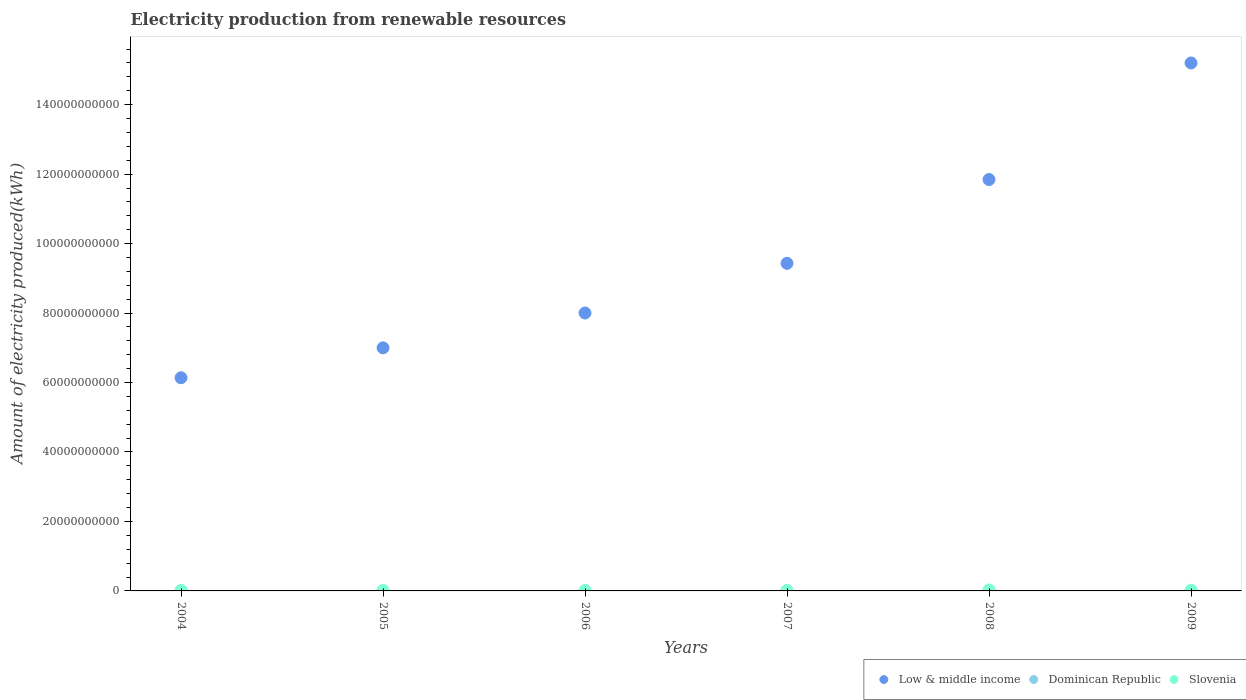How many different coloured dotlines are there?
Give a very brief answer. 3. What is the amount of electricity produced in Low & middle income in 2004?
Provide a short and direct response. 6.14e+1. Across all years, what is the maximum amount of electricity produced in Low & middle income?
Keep it short and to the point. 1.52e+11. Across all years, what is the minimum amount of electricity produced in Low & middle income?
Provide a short and direct response. 6.14e+1. In which year was the amount of electricity produced in Dominican Republic maximum?
Give a very brief answer. 2004. What is the total amount of electricity produced in Low & middle income in the graph?
Give a very brief answer. 5.76e+11. What is the difference between the amount of electricity produced in Low & middle income in 2007 and that in 2008?
Offer a very short reply. -2.41e+1. What is the difference between the amount of electricity produced in Low & middle income in 2006 and the amount of electricity produced in Slovenia in 2005?
Provide a succinct answer. 7.99e+1. What is the average amount of electricity produced in Dominican Republic per year?
Provide a succinct answer. 3.68e+07. In the year 2009, what is the difference between the amount of electricity produced in Low & middle income and amount of electricity produced in Dominican Republic?
Give a very brief answer. 1.52e+11. In how many years, is the amount of electricity produced in Slovenia greater than 128000000000 kWh?
Your answer should be very brief. 0. What is the ratio of the amount of electricity produced in Low & middle income in 2004 to that in 2006?
Give a very brief answer. 0.77. Is the amount of electricity produced in Slovenia in 2006 less than that in 2007?
Offer a very short reply. Yes. Is the difference between the amount of electricity produced in Low & middle income in 2005 and 2007 greater than the difference between the amount of electricity produced in Dominican Republic in 2005 and 2007?
Offer a terse response. No. What is the difference between the highest and the second highest amount of electricity produced in Dominican Republic?
Your answer should be very brief. 3.30e+07. What is the difference between the highest and the lowest amount of electricity produced in Slovenia?
Your answer should be compact. 1.78e+08. Is the sum of the amount of electricity produced in Low & middle income in 2007 and 2009 greater than the maximum amount of electricity produced in Dominican Republic across all years?
Ensure brevity in your answer.  Yes. Is it the case that in every year, the sum of the amount of electricity produced in Slovenia and amount of electricity produced in Dominican Republic  is greater than the amount of electricity produced in Low & middle income?
Ensure brevity in your answer.  No. Is the amount of electricity produced in Dominican Republic strictly greater than the amount of electricity produced in Slovenia over the years?
Make the answer very short. No. Is the amount of electricity produced in Dominican Republic strictly less than the amount of electricity produced in Slovenia over the years?
Make the answer very short. Yes. How many dotlines are there?
Provide a succinct answer. 3. What is the difference between two consecutive major ticks on the Y-axis?
Offer a very short reply. 2.00e+1. Does the graph contain any zero values?
Keep it short and to the point. No. Does the graph contain grids?
Provide a short and direct response. No. Where does the legend appear in the graph?
Give a very brief answer. Bottom right. How many legend labels are there?
Keep it short and to the point. 3. What is the title of the graph?
Your response must be concise. Electricity production from renewable resources. Does "Armenia" appear as one of the legend labels in the graph?
Your answer should be compact. No. What is the label or title of the X-axis?
Provide a short and direct response. Years. What is the label or title of the Y-axis?
Keep it short and to the point. Amount of electricity produced(kWh). What is the Amount of electricity produced(kWh) of Low & middle income in 2004?
Your answer should be very brief. 6.14e+1. What is the Amount of electricity produced(kWh) of Dominican Republic in 2004?
Offer a very short reply. 7.00e+07. What is the Amount of electricity produced(kWh) of Slovenia in 2004?
Provide a short and direct response. 1.21e+08. What is the Amount of electricity produced(kWh) of Low & middle income in 2005?
Your answer should be compact. 7.00e+1. What is the Amount of electricity produced(kWh) in Dominican Republic in 2005?
Offer a very short reply. 2.90e+07. What is the Amount of electricity produced(kWh) of Slovenia in 2005?
Keep it short and to the point. 1.14e+08. What is the Amount of electricity produced(kWh) in Low & middle income in 2006?
Give a very brief answer. 8.00e+1. What is the Amount of electricity produced(kWh) in Dominican Republic in 2006?
Offer a terse response. 2.80e+07. What is the Amount of electricity produced(kWh) in Slovenia in 2006?
Keep it short and to the point. 1.12e+08. What is the Amount of electricity produced(kWh) in Low & middle income in 2007?
Make the answer very short. 9.43e+1. What is the Amount of electricity produced(kWh) of Dominican Republic in 2007?
Make the answer very short. 3.70e+07. What is the Amount of electricity produced(kWh) of Slovenia in 2007?
Ensure brevity in your answer.  1.13e+08. What is the Amount of electricity produced(kWh) in Low & middle income in 2008?
Make the answer very short. 1.18e+11. What is the Amount of electricity produced(kWh) of Dominican Republic in 2008?
Offer a very short reply. 2.90e+07. What is the Amount of electricity produced(kWh) in Slovenia in 2008?
Ensure brevity in your answer.  2.90e+08. What is the Amount of electricity produced(kWh) of Low & middle income in 2009?
Offer a very short reply. 1.52e+11. What is the Amount of electricity produced(kWh) in Dominican Republic in 2009?
Your response must be concise. 2.80e+07. What is the Amount of electricity produced(kWh) in Slovenia in 2009?
Give a very brief answer. 1.92e+08. Across all years, what is the maximum Amount of electricity produced(kWh) of Low & middle income?
Offer a terse response. 1.52e+11. Across all years, what is the maximum Amount of electricity produced(kWh) of Dominican Republic?
Your response must be concise. 7.00e+07. Across all years, what is the maximum Amount of electricity produced(kWh) in Slovenia?
Your answer should be compact. 2.90e+08. Across all years, what is the minimum Amount of electricity produced(kWh) in Low & middle income?
Ensure brevity in your answer.  6.14e+1. Across all years, what is the minimum Amount of electricity produced(kWh) of Dominican Republic?
Provide a short and direct response. 2.80e+07. Across all years, what is the minimum Amount of electricity produced(kWh) of Slovenia?
Your answer should be very brief. 1.12e+08. What is the total Amount of electricity produced(kWh) in Low & middle income in the graph?
Keep it short and to the point. 5.76e+11. What is the total Amount of electricity produced(kWh) of Dominican Republic in the graph?
Ensure brevity in your answer.  2.21e+08. What is the total Amount of electricity produced(kWh) of Slovenia in the graph?
Offer a terse response. 9.42e+08. What is the difference between the Amount of electricity produced(kWh) of Low & middle income in 2004 and that in 2005?
Offer a terse response. -8.62e+09. What is the difference between the Amount of electricity produced(kWh) in Dominican Republic in 2004 and that in 2005?
Keep it short and to the point. 4.10e+07. What is the difference between the Amount of electricity produced(kWh) of Low & middle income in 2004 and that in 2006?
Keep it short and to the point. -1.86e+1. What is the difference between the Amount of electricity produced(kWh) in Dominican Republic in 2004 and that in 2006?
Offer a very short reply. 4.20e+07. What is the difference between the Amount of electricity produced(kWh) of Slovenia in 2004 and that in 2006?
Your answer should be very brief. 9.00e+06. What is the difference between the Amount of electricity produced(kWh) of Low & middle income in 2004 and that in 2007?
Offer a very short reply. -3.29e+1. What is the difference between the Amount of electricity produced(kWh) in Dominican Republic in 2004 and that in 2007?
Keep it short and to the point. 3.30e+07. What is the difference between the Amount of electricity produced(kWh) in Low & middle income in 2004 and that in 2008?
Offer a very short reply. -5.71e+1. What is the difference between the Amount of electricity produced(kWh) of Dominican Republic in 2004 and that in 2008?
Give a very brief answer. 4.10e+07. What is the difference between the Amount of electricity produced(kWh) of Slovenia in 2004 and that in 2008?
Your answer should be very brief. -1.69e+08. What is the difference between the Amount of electricity produced(kWh) in Low & middle income in 2004 and that in 2009?
Offer a terse response. -9.06e+1. What is the difference between the Amount of electricity produced(kWh) of Dominican Republic in 2004 and that in 2009?
Keep it short and to the point. 4.20e+07. What is the difference between the Amount of electricity produced(kWh) in Slovenia in 2004 and that in 2009?
Make the answer very short. -7.10e+07. What is the difference between the Amount of electricity produced(kWh) of Low & middle income in 2005 and that in 2006?
Your response must be concise. -1.00e+1. What is the difference between the Amount of electricity produced(kWh) of Dominican Republic in 2005 and that in 2006?
Ensure brevity in your answer.  1.00e+06. What is the difference between the Amount of electricity produced(kWh) in Slovenia in 2005 and that in 2006?
Your answer should be very brief. 2.00e+06. What is the difference between the Amount of electricity produced(kWh) of Low & middle income in 2005 and that in 2007?
Your response must be concise. -2.43e+1. What is the difference between the Amount of electricity produced(kWh) in Dominican Republic in 2005 and that in 2007?
Provide a succinct answer. -8.00e+06. What is the difference between the Amount of electricity produced(kWh) of Low & middle income in 2005 and that in 2008?
Make the answer very short. -4.85e+1. What is the difference between the Amount of electricity produced(kWh) of Slovenia in 2005 and that in 2008?
Keep it short and to the point. -1.76e+08. What is the difference between the Amount of electricity produced(kWh) of Low & middle income in 2005 and that in 2009?
Offer a very short reply. -8.20e+1. What is the difference between the Amount of electricity produced(kWh) in Dominican Republic in 2005 and that in 2009?
Your answer should be compact. 1.00e+06. What is the difference between the Amount of electricity produced(kWh) of Slovenia in 2005 and that in 2009?
Make the answer very short. -7.80e+07. What is the difference between the Amount of electricity produced(kWh) in Low & middle income in 2006 and that in 2007?
Provide a short and direct response. -1.43e+1. What is the difference between the Amount of electricity produced(kWh) of Dominican Republic in 2006 and that in 2007?
Ensure brevity in your answer.  -9.00e+06. What is the difference between the Amount of electricity produced(kWh) of Low & middle income in 2006 and that in 2008?
Offer a very short reply. -3.84e+1. What is the difference between the Amount of electricity produced(kWh) of Slovenia in 2006 and that in 2008?
Provide a succinct answer. -1.78e+08. What is the difference between the Amount of electricity produced(kWh) of Low & middle income in 2006 and that in 2009?
Give a very brief answer. -7.20e+1. What is the difference between the Amount of electricity produced(kWh) of Slovenia in 2006 and that in 2009?
Your response must be concise. -8.00e+07. What is the difference between the Amount of electricity produced(kWh) in Low & middle income in 2007 and that in 2008?
Your answer should be very brief. -2.41e+1. What is the difference between the Amount of electricity produced(kWh) of Dominican Republic in 2007 and that in 2008?
Keep it short and to the point. 8.00e+06. What is the difference between the Amount of electricity produced(kWh) in Slovenia in 2007 and that in 2008?
Keep it short and to the point. -1.77e+08. What is the difference between the Amount of electricity produced(kWh) in Low & middle income in 2007 and that in 2009?
Provide a short and direct response. -5.77e+1. What is the difference between the Amount of electricity produced(kWh) in Dominican Republic in 2007 and that in 2009?
Your response must be concise. 9.00e+06. What is the difference between the Amount of electricity produced(kWh) in Slovenia in 2007 and that in 2009?
Your response must be concise. -7.90e+07. What is the difference between the Amount of electricity produced(kWh) of Low & middle income in 2008 and that in 2009?
Keep it short and to the point. -3.36e+1. What is the difference between the Amount of electricity produced(kWh) in Slovenia in 2008 and that in 2009?
Keep it short and to the point. 9.80e+07. What is the difference between the Amount of electricity produced(kWh) in Low & middle income in 2004 and the Amount of electricity produced(kWh) in Dominican Republic in 2005?
Ensure brevity in your answer.  6.13e+1. What is the difference between the Amount of electricity produced(kWh) of Low & middle income in 2004 and the Amount of electricity produced(kWh) of Slovenia in 2005?
Your answer should be very brief. 6.13e+1. What is the difference between the Amount of electricity produced(kWh) of Dominican Republic in 2004 and the Amount of electricity produced(kWh) of Slovenia in 2005?
Your response must be concise. -4.40e+07. What is the difference between the Amount of electricity produced(kWh) in Low & middle income in 2004 and the Amount of electricity produced(kWh) in Dominican Republic in 2006?
Provide a succinct answer. 6.13e+1. What is the difference between the Amount of electricity produced(kWh) of Low & middle income in 2004 and the Amount of electricity produced(kWh) of Slovenia in 2006?
Your answer should be compact. 6.13e+1. What is the difference between the Amount of electricity produced(kWh) of Dominican Republic in 2004 and the Amount of electricity produced(kWh) of Slovenia in 2006?
Offer a very short reply. -4.20e+07. What is the difference between the Amount of electricity produced(kWh) in Low & middle income in 2004 and the Amount of electricity produced(kWh) in Dominican Republic in 2007?
Provide a succinct answer. 6.13e+1. What is the difference between the Amount of electricity produced(kWh) in Low & middle income in 2004 and the Amount of electricity produced(kWh) in Slovenia in 2007?
Give a very brief answer. 6.13e+1. What is the difference between the Amount of electricity produced(kWh) in Dominican Republic in 2004 and the Amount of electricity produced(kWh) in Slovenia in 2007?
Your response must be concise. -4.30e+07. What is the difference between the Amount of electricity produced(kWh) of Low & middle income in 2004 and the Amount of electricity produced(kWh) of Dominican Republic in 2008?
Offer a very short reply. 6.13e+1. What is the difference between the Amount of electricity produced(kWh) in Low & middle income in 2004 and the Amount of electricity produced(kWh) in Slovenia in 2008?
Ensure brevity in your answer.  6.11e+1. What is the difference between the Amount of electricity produced(kWh) in Dominican Republic in 2004 and the Amount of electricity produced(kWh) in Slovenia in 2008?
Offer a very short reply. -2.20e+08. What is the difference between the Amount of electricity produced(kWh) of Low & middle income in 2004 and the Amount of electricity produced(kWh) of Dominican Republic in 2009?
Offer a terse response. 6.13e+1. What is the difference between the Amount of electricity produced(kWh) in Low & middle income in 2004 and the Amount of electricity produced(kWh) in Slovenia in 2009?
Ensure brevity in your answer.  6.12e+1. What is the difference between the Amount of electricity produced(kWh) in Dominican Republic in 2004 and the Amount of electricity produced(kWh) in Slovenia in 2009?
Your answer should be compact. -1.22e+08. What is the difference between the Amount of electricity produced(kWh) in Low & middle income in 2005 and the Amount of electricity produced(kWh) in Dominican Republic in 2006?
Provide a succinct answer. 7.00e+1. What is the difference between the Amount of electricity produced(kWh) of Low & middle income in 2005 and the Amount of electricity produced(kWh) of Slovenia in 2006?
Your answer should be compact. 6.99e+1. What is the difference between the Amount of electricity produced(kWh) in Dominican Republic in 2005 and the Amount of electricity produced(kWh) in Slovenia in 2006?
Ensure brevity in your answer.  -8.30e+07. What is the difference between the Amount of electricity produced(kWh) in Low & middle income in 2005 and the Amount of electricity produced(kWh) in Dominican Republic in 2007?
Offer a very short reply. 6.99e+1. What is the difference between the Amount of electricity produced(kWh) in Low & middle income in 2005 and the Amount of electricity produced(kWh) in Slovenia in 2007?
Your answer should be compact. 6.99e+1. What is the difference between the Amount of electricity produced(kWh) in Dominican Republic in 2005 and the Amount of electricity produced(kWh) in Slovenia in 2007?
Your response must be concise. -8.40e+07. What is the difference between the Amount of electricity produced(kWh) in Low & middle income in 2005 and the Amount of electricity produced(kWh) in Dominican Republic in 2008?
Provide a succinct answer. 7.00e+1. What is the difference between the Amount of electricity produced(kWh) in Low & middle income in 2005 and the Amount of electricity produced(kWh) in Slovenia in 2008?
Your response must be concise. 6.97e+1. What is the difference between the Amount of electricity produced(kWh) of Dominican Republic in 2005 and the Amount of electricity produced(kWh) of Slovenia in 2008?
Give a very brief answer. -2.61e+08. What is the difference between the Amount of electricity produced(kWh) in Low & middle income in 2005 and the Amount of electricity produced(kWh) in Dominican Republic in 2009?
Give a very brief answer. 7.00e+1. What is the difference between the Amount of electricity produced(kWh) in Low & middle income in 2005 and the Amount of electricity produced(kWh) in Slovenia in 2009?
Offer a very short reply. 6.98e+1. What is the difference between the Amount of electricity produced(kWh) in Dominican Republic in 2005 and the Amount of electricity produced(kWh) in Slovenia in 2009?
Offer a very short reply. -1.63e+08. What is the difference between the Amount of electricity produced(kWh) of Low & middle income in 2006 and the Amount of electricity produced(kWh) of Dominican Republic in 2007?
Your response must be concise. 8.00e+1. What is the difference between the Amount of electricity produced(kWh) of Low & middle income in 2006 and the Amount of electricity produced(kWh) of Slovenia in 2007?
Keep it short and to the point. 7.99e+1. What is the difference between the Amount of electricity produced(kWh) of Dominican Republic in 2006 and the Amount of electricity produced(kWh) of Slovenia in 2007?
Offer a terse response. -8.50e+07. What is the difference between the Amount of electricity produced(kWh) of Low & middle income in 2006 and the Amount of electricity produced(kWh) of Dominican Republic in 2008?
Offer a very short reply. 8.00e+1. What is the difference between the Amount of electricity produced(kWh) of Low & middle income in 2006 and the Amount of electricity produced(kWh) of Slovenia in 2008?
Offer a terse response. 7.97e+1. What is the difference between the Amount of electricity produced(kWh) in Dominican Republic in 2006 and the Amount of electricity produced(kWh) in Slovenia in 2008?
Offer a terse response. -2.62e+08. What is the difference between the Amount of electricity produced(kWh) in Low & middle income in 2006 and the Amount of electricity produced(kWh) in Dominican Republic in 2009?
Offer a terse response. 8.00e+1. What is the difference between the Amount of electricity produced(kWh) in Low & middle income in 2006 and the Amount of electricity produced(kWh) in Slovenia in 2009?
Provide a short and direct response. 7.98e+1. What is the difference between the Amount of electricity produced(kWh) in Dominican Republic in 2006 and the Amount of electricity produced(kWh) in Slovenia in 2009?
Your response must be concise. -1.64e+08. What is the difference between the Amount of electricity produced(kWh) in Low & middle income in 2007 and the Amount of electricity produced(kWh) in Dominican Republic in 2008?
Your response must be concise. 9.43e+1. What is the difference between the Amount of electricity produced(kWh) in Low & middle income in 2007 and the Amount of electricity produced(kWh) in Slovenia in 2008?
Keep it short and to the point. 9.40e+1. What is the difference between the Amount of electricity produced(kWh) of Dominican Republic in 2007 and the Amount of electricity produced(kWh) of Slovenia in 2008?
Offer a terse response. -2.53e+08. What is the difference between the Amount of electricity produced(kWh) of Low & middle income in 2007 and the Amount of electricity produced(kWh) of Dominican Republic in 2009?
Offer a very short reply. 9.43e+1. What is the difference between the Amount of electricity produced(kWh) in Low & middle income in 2007 and the Amount of electricity produced(kWh) in Slovenia in 2009?
Offer a very short reply. 9.41e+1. What is the difference between the Amount of electricity produced(kWh) in Dominican Republic in 2007 and the Amount of electricity produced(kWh) in Slovenia in 2009?
Your answer should be compact. -1.55e+08. What is the difference between the Amount of electricity produced(kWh) in Low & middle income in 2008 and the Amount of electricity produced(kWh) in Dominican Republic in 2009?
Ensure brevity in your answer.  1.18e+11. What is the difference between the Amount of electricity produced(kWh) of Low & middle income in 2008 and the Amount of electricity produced(kWh) of Slovenia in 2009?
Offer a terse response. 1.18e+11. What is the difference between the Amount of electricity produced(kWh) of Dominican Republic in 2008 and the Amount of electricity produced(kWh) of Slovenia in 2009?
Provide a succinct answer. -1.63e+08. What is the average Amount of electricity produced(kWh) in Low & middle income per year?
Provide a short and direct response. 9.60e+1. What is the average Amount of electricity produced(kWh) in Dominican Republic per year?
Offer a terse response. 3.68e+07. What is the average Amount of electricity produced(kWh) in Slovenia per year?
Keep it short and to the point. 1.57e+08. In the year 2004, what is the difference between the Amount of electricity produced(kWh) of Low & middle income and Amount of electricity produced(kWh) of Dominican Republic?
Your answer should be very brief. 6.13e+1. In the year 2004, what is the difference between the Amount of electricity produced(kWh) in Low & middle income and Amount of electricity produced(kWh) in Slovenia?
Ensure brevity in your answer.  6.12e+1. In the year 2004, what is the difference between the Amount of electricity produced(kWh) in Dominican Republic and Amount of electricity produced(kWh) in Slovenia?
Offer a very short reply. -5.10e+07. In the year 2005, what is the difference between the Amount of electricity produced(kWh) in Low & middle income and Amount of electricity produced(kWh) in Dominican Republic?
Keep it short and to the point. 7.00e+1. In the year 2005, what is the difference between the Amount of electricity produced(kWh) in Low & middle income and Amount of electricity produced(kWh) in Slovenia?
Provide a short and direct response. 6.99e+1. In the year 2005, what is the difference between the Amount of electricity produced(kWh) of Dominican Republic and Amount of electricity produced(kWh) of Slovenia?
Your response must be concise. -8.50e+07. In the year 2006, what is the difference between the Amount of electricity produced(kWh) of Low & middle income and Amount of electricity produced(kWh) of Dominican Republic?
Make the answer very short. 8.00e+1. In the year 2006, what is the difference between the Amount of electricity produced(kWh) of Low & middle income and Amount of electricity produced(kWh) of Slovenia?
Provide a short and direct response. 7.99e+1. In the year 2006, what is the difference between the Amount of electricity produced(kWh) in Dominican Republic and Amount of electricity produced(kWh) in Slovenia?
Your response must be concise. -8.40e+07. In the year 2007, what is the difference between the Amount of electricity produced(kWh) of Low & middle income and Amount of electricity produced(kWh) of Dominican Republic?
Keep it short and to the point. 9.43e+1. In the year 2007, what is the difference between the Amount of electricity produced(kWh) in Low & middle income and Amount of electricity produced(kWh) in Slovenia?
Ensure brevity in your answer.  9.42e+1. In the year 2007, what is the difference between the Amount of electricity produced(kWh) in Dominican Republic and Amount of electricity produced(kWh) in Slovenia?
Ensure brevity in your answer.  -7.60e+07. In the year 2008, what is the difference between the Amount of electricity produced(kWh) of Low & middle income and Amount of electricity produced(kWh) of Dominican Republic?
Provide a short and direct response. 1.18e+11. In the year 2008, what is the difference between the Amount of electricity produced(kWh) in Low & middle income and Amount of electricity produced(kWh) in Slovenia?
Offer a very short reply. 1.18e+11. In the year 2008, what is the difference between the Amount of electricity produced(kWh) in Dominican Republic and Amount of electricity produced(kWh) in Slovenia?
Give a very brief answer. -2.61e+08. In the year 2009, what is the difference between the Amount of electricity produced(kWh) of Low & middle income and Amount of electricity produced(kWh) of Dominican Republic?
Keep it short and to the point. 1.52e+11. In the year 2009, what is the difference between the Amount of electricity produced(kWh) of Low & middle income and Amount of electricity produced(kWh) of Slovenia?
Provide a succinct answer. 1.52e+11. In the year 2009, what is the difference between the Amount of electricity produced(kWh) of Dominican Republic and Amount of electricity produced(kWh) of Slovenia?
Offer a terse response. -1.64e+08. What is the ratio of the Amount of electricity produced(kWh) of Low & middle income in 2004 to that in 2005?
Offer a very short reply. 0.88. What is the ratio of the Amount of electricity produced(kWh) in Dominican Republic in 2004 to that in 2005?
Your response must be concise. 2.41. What is the ratio of the Amount of electricity produced(kWh) of Slovenia in 2004 to that in 2005?
Your response must be concise. 1.06. What is the ratio of the Amount of electricity produced(kWh) in Low & middle income in 2004 to that in 2006?
Provide a short and direct response. 0.77. What is the ratio of the Amount of electricity produced(kWh) of Slovenia in 2004 to that in 2006?
Your answer should be very brief. 1.08. What is the ratio of the Amount of electricity produced(kWh) in Low & middle income in 2004 to that in 2007?
Make the answer very short. 0.65. What is the ratio of the Amount of electricity produced(kWh) in Dominican Republic in 2004 to that in 2007?
Keep it short and to the point. 1.89. What is the ratio of the Amount of electricity produced(kWh) of Slovenia in 2004 to that in 2007?
Ensure brevity in your answer.  1.07. What is the ratio of the Amount of electricity produced(kWh) in Low & middle income in 2004 to that in 2008?
Provide a short and direct response. 0.52. What is the ratio of the Amount of electricity produced(kWh) in Dominican Republic in 2004 to that in 2008?
Give a very brief answer. 2.41. What is the ratio of the Amount of electricity produced(kWh) of Slovenia in 2004 to that in 2008?
Provide a succinct answer. 0.42. What is the ratio of the Amount of electricity produced(kWh) in Low & middle income in 2004 to that in 2009?
Keep it short and to the point. 0.4. What is the ratio of the Amount of electricity produced(kWh) of Dominican Republic in 2004 to that in 2009?
Give a very brief answer. 2.5. What is the ratio of the Amount of electricity produced(kWh) of Slovenia in 2004 to that in 2009?
Provide a succinct answer. 0.63. What is the ratio of the Amount of electricity produced(kWh) in Low & middle income in 2005 to that in 2006?
Your response must be concise. 0.87. What is the ratio of the Amount of electricity produced(kWh) in Dominican Republic in 2005 to that in 2006?
Your answer should be very brief. 1.04. What is the ratio of the Amount of electricity produced(kWh) in Slovenia in 2005 to that in 2006?
Provide a succinct answer. 1.02. What is the ratio of the Amount of electricity produced(kWh) in Low & middle income in 2005 to that in 2007?
Your answer should be compact. 0.74. What is the ratio of the Amount of electricity produced(kWh) in Dominican Republic in 2005 to that in 2007?
Offer a terse response. 0.78. What is the ratio of the Amount of electricity produced(kWh) of Slovenia in 2005 to that in 2007?
Offer a terse response. 1.01. What is the ratio of the Amount of electricity produced(kWh) of Low & middle income in 2005 to that in 2008?
Your response must be concise. 0.59. What is the ratio of the Amount of electricity produced(kWh) of Slovenia in 2005 to that in 2008?
Give a very brief answer. 0.39. What is the ratio of the Amount of electricity produced(kWh) in Low & middle income in 2005 to that in 2009?
Keep it short and to the point. 0.46. What is the ratio of the Amount of electricity produced(kWh) in Dominican Republic in 2005 to that in 2009?
Give a very brief answer. 1.04. What is the ratio of the Amount of electricity produced(kWh) in Slovenia in 2005 to that in 2009?
Keep it short and to the point. 0.59. What is the ratio of the Amount of electricity produced(kWh) of Low & middle income in 2006 to that in 2007?
Offer a terse response. 0.85. What is the ratio of the Amount of electricity produced(kWh) of Dominican Republic in 2006 to that in 2007?
Provide a succinct answer. 0.76. What is the ratio of the Amount of electricity produced(kWh) of Low & middle income in 2006 to that in 2008?
Ensure brevity in your answer.  0.68. What is the ratio of the Amount of electricity produced(kWh) in Dominican Republic in 2006 to that in 2008?
Provide a short and direct response. 0.97. What is the ratio of the Amount of electricity produced(kWh) in Slovenia in 2006 to that in 2008?
Offer a terse response. 0.39. What is the ratio of the Amount of electricity produced(kWh) of Low & middle income in 2006 to that in 2009?
Make the answer very short. 0.53. What is the ratio of the Amount of electricity produced(kWh) of Slovenia in 2006 to that in 2009?
Ensure brevity in your answer.  0.58. What is the ratio of the Amount of electricity produced(kWh) of Low & middle income in 2007 to that in 2008?
Keep it short and to the point. 0.8. What is the ratio of the Amount of electricity produced(kWh) in Dominican Republic in 2007 to that in 2008?
Your answer should be very brief. 1.28. What is the ratio of the Amount of electricity produced(kWh) of Slovenia in 2007 to that in 2008?
Your answer should be very brief. 0.39. What is the ratio of the Amount of electricity produced(kWh) of Low & middle income in 2007 to that in 2009?
Your answer should be very brief. 0.62. What is the ratio of the Amount of electricity produced(kWh) of Dominican Republic in 2007 to that in 2009?
Provide a succinct answer. 1.32. What is the ratio of the Amount of electricity produced(kWh) in Slovenia in 2007 to that in 2009?
Ensure brevity in your answer.  0.59. What is the ratio of the Amount of electricity produced(kWh) of Low & middle income in 2008 to that in 2009?
Your response must be concise. 0.78. What is the ratio of the Amount of electricity produced(kWh) in Dominican Republic in 2008 to that in 2009?
Offer a very short reply. 1.04. What is the ratio of the Amount of electricity produced(kWh) of Slovenia in 2008 to that in 2009?
Provide a succinct answer. 1.51. What is the difference between the highest and the second highest Amount of electricity produced(kWh) in Low & middle income?
Your response must be concise. 3.36e+1. What is the difference between the highest and the second highest Amount of electricity produced(kWh) in Dominican Republic?
Ensure brevity in your answer.  3.30e+07. What is the difference between the highest and the second highest Amount of electricity produced(kWh) in Slovenia?
Provide a short and direct response. 9.80e+07. What is the difference between the highest and the lowest Amount of electricity produced(kWh) of Low & middle income?
Provide a succinct answer. 9.06e+1. What is the difference between the highest and the lowest Amount of electricity produced(kWh) in Dominican Republic?
Your answer should be compact. 4.20e+07. What is the difference between the highest and the lowest Amount of electricity produced(kWh) of Slovenia?
Offer a very short reply. 1.78e+08. 